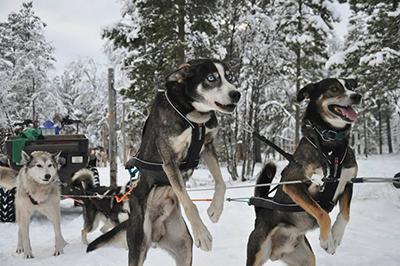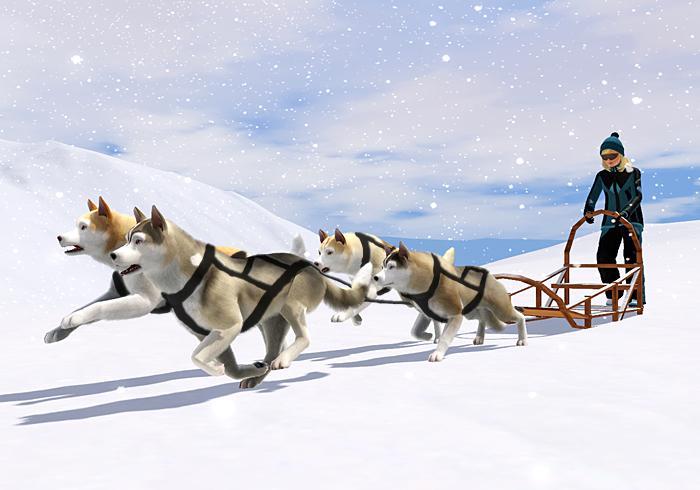The first image is the image on the left, the second image is the image on the right. Evaluate the accuracy of this statement regarding the images: "Some dogs are wearing booties.". Is it true? Answer yes or no. No. The first image is the image on the left, the second image is the image on the right. Given the left and right images, does the statement "One image shows a sled dog team with a standing sled driver in back moving across the snow, and the other image features at least one creature standing up on two legs." hold true? Answer yes or no. Yes. 